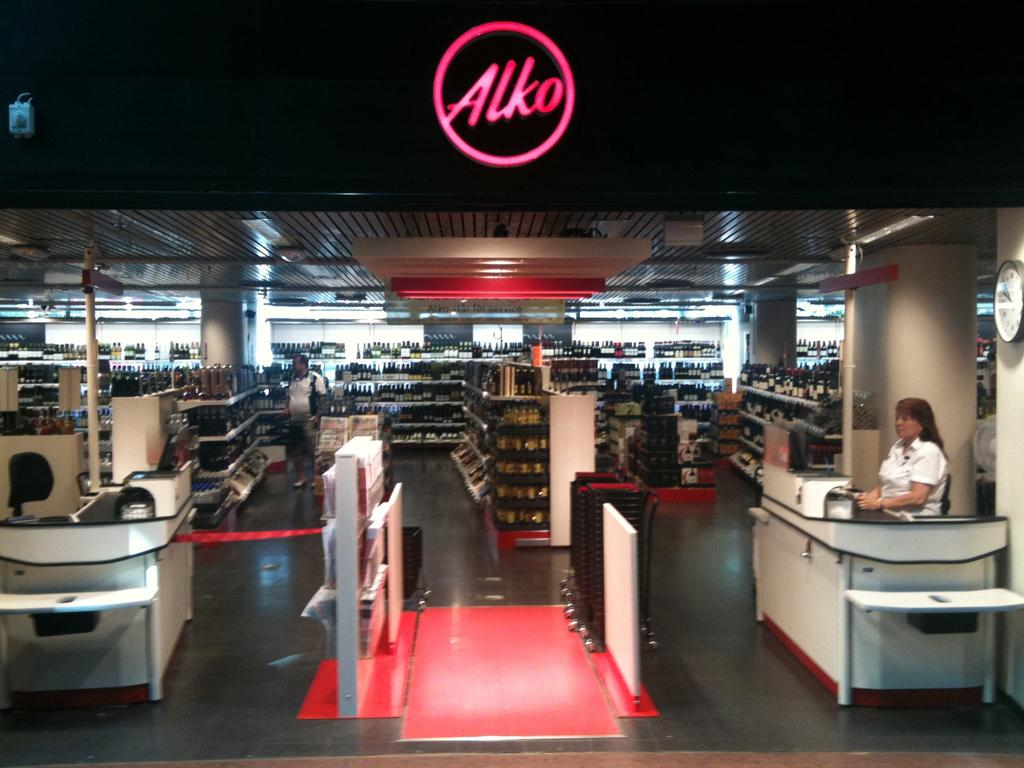<image>
Offer a succinct explanation of the picture presented. a store with many items and an Alko sign 